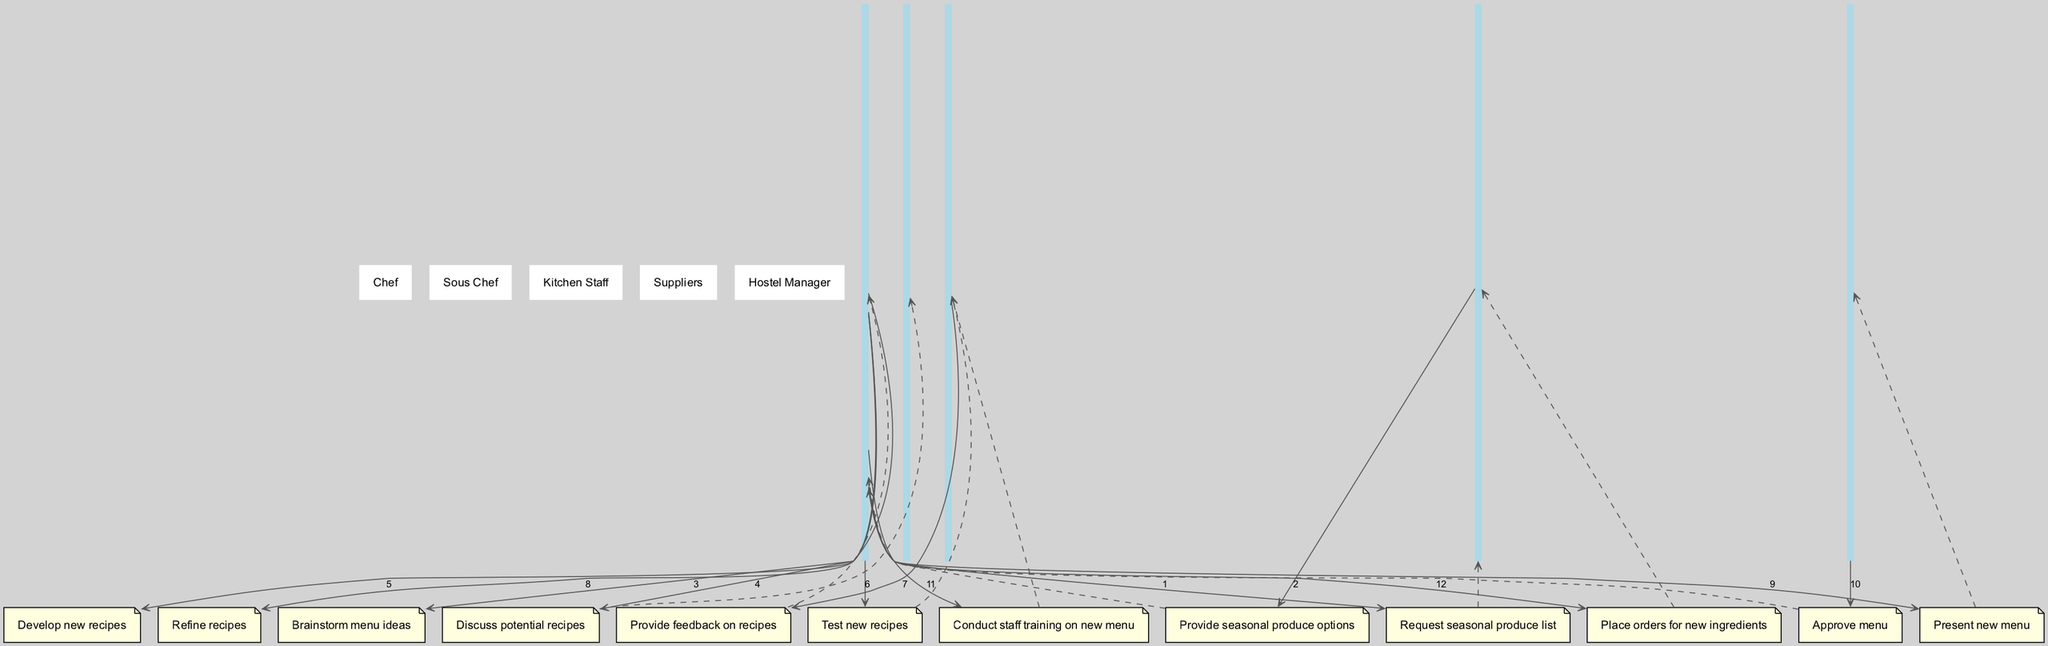What is the first action in the sequence? The first action in the sequence is initiated by the Chef who "Requests seasonal produce list" from the Suppliers. This is the starting point of the sequence depicted in the diagram.
Answer: Request seasonal produce list How many actors are involved in the sequence? There are five actors involved in the sequence: Chef, Sous Chef, Kitchen Staff, Suppliers, and Hostel Manager. This can be counted directly from the actor list in the diagram.
Answer: Five Which actor provides feedback on the recipes? The Kitchen Staff provides feedback on the recipes to the Chef after testing the new recipes. This relationship is indicated by the arrows connecting both actors in the sequence.
Answer: Kitchen Staff What step follows the approval of the menu by the Hostel Manager? After the Hostel Manager approves the menu, the Chef conducts staff training on the new menu. This step is directly linked in the sequence flow following the approval action.
Answer: Conduct staff training on new menu Which actor is responsible for placing orders for new ingredients? The Chef is responsible for placing orders for new ingredients after presenting the new menu to the Hostel Manager and receiving approval. This is the last action in the sequence.
Answer: Chef How many steps are taken between developing new recipes and conducting staff training? There are three steps taken between developing new recipes and conducting staff training: testing new recipes, providing feedback on recipes, and refining recipes. This can be found by counting the actions in the sequence that fall between these two points.
Answer: Three Which action is a discussion about potential recipes? The action that involves discussion about potential recipes is when the Chef discusses potential recipes with the Sous Chef. This step specifically highlights collaboration on recipe development.
Answer: Discuss potential recipes What is the last action in the sequence? The last action in the sequence is for the Chef to "Place orders for new ingredients". This signifies the final step in the process after all prior actions have been completed.
Answer: Place orders for new ingredients 